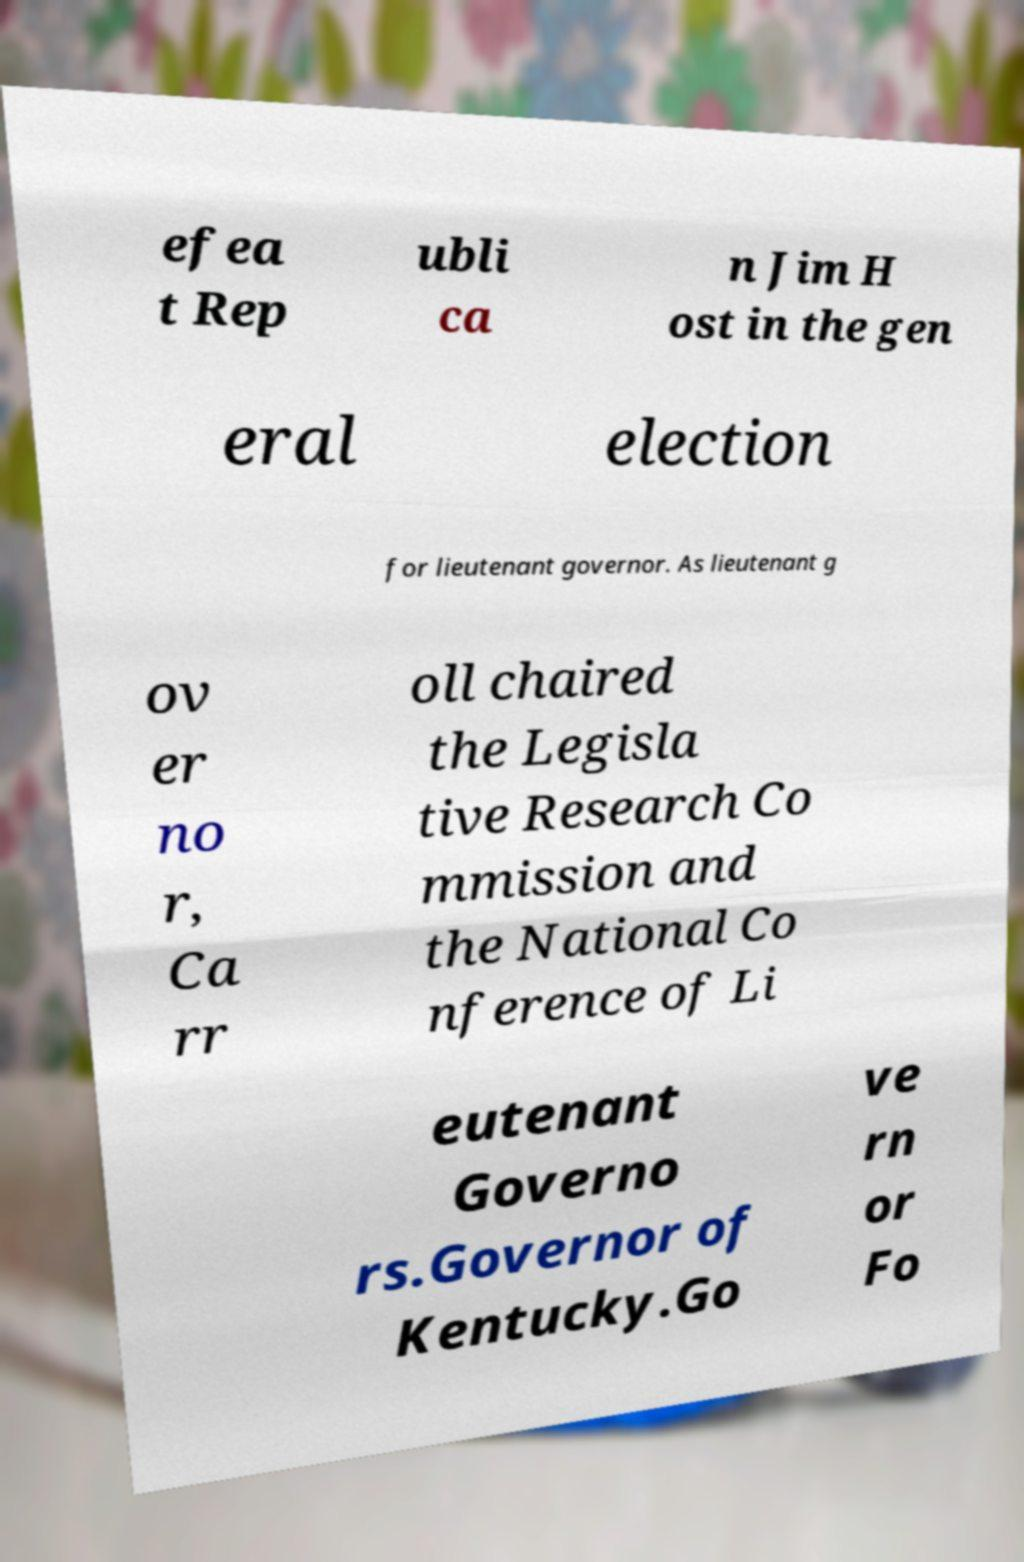Please read and relay the text visible in this image. What does it say? efea t Rep ubli ca n Jim H ost in the gen eral election for lieutenant governor. As lieutenant g ov er no r, Ca rr oll chaired the Legisla tive Research Co mmission and the National Co nference of Li eutenant Governo rs.Governor of Kentucky.Go ve rn or Fo 